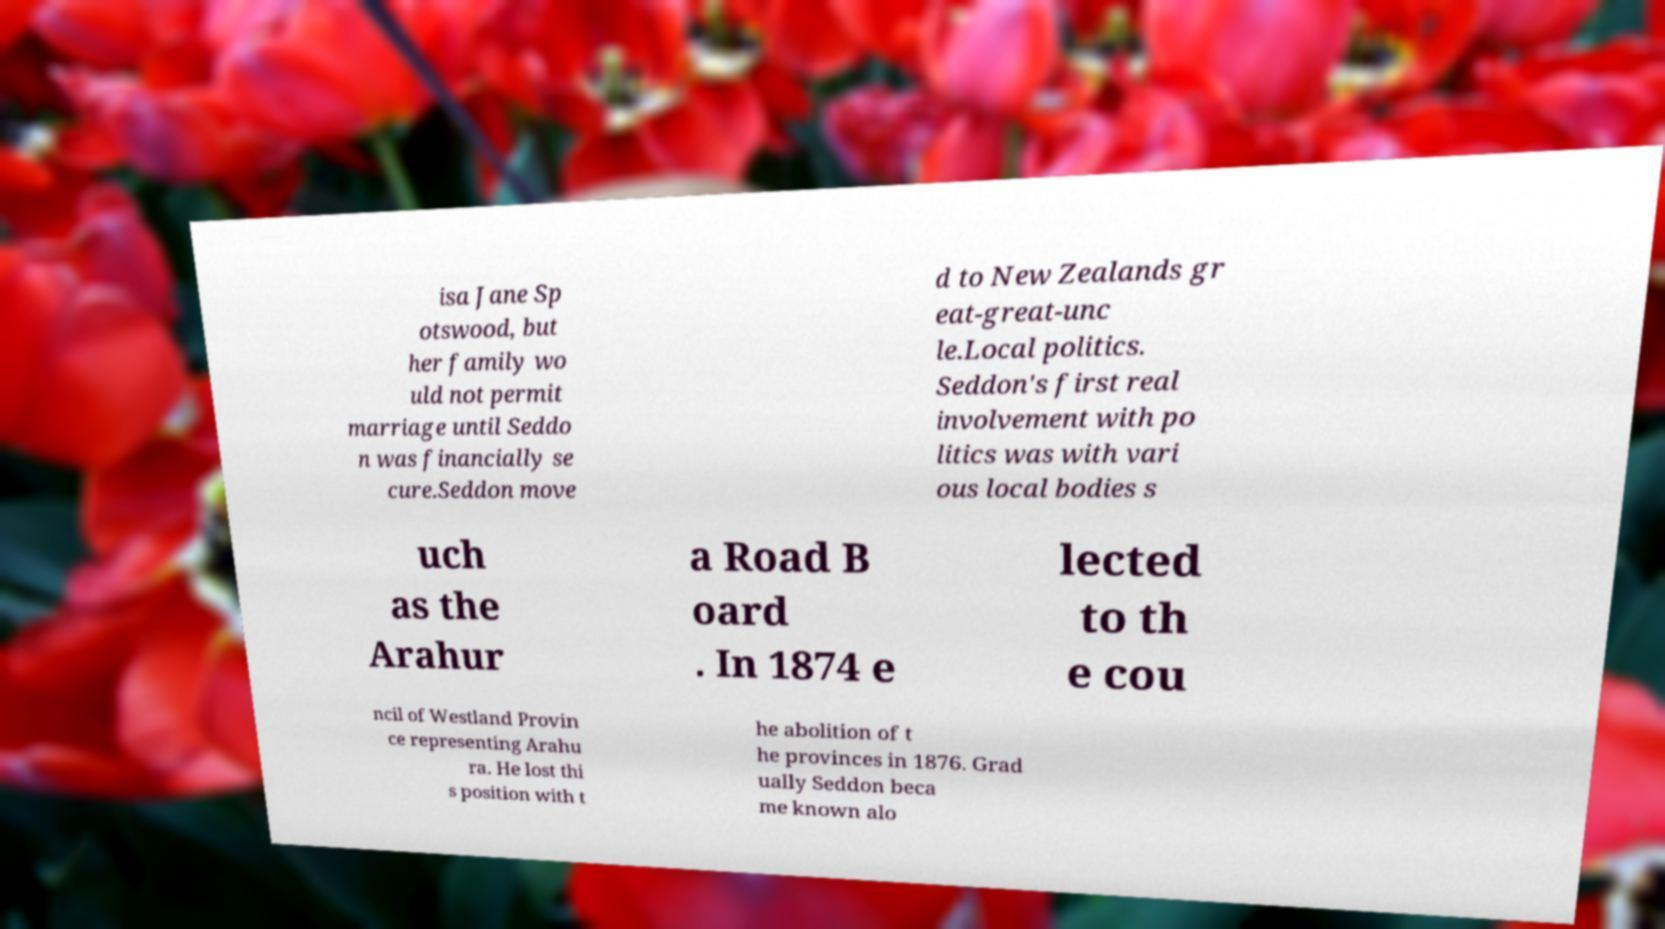There's text embedded in this image that I need extracted. Can you transcribe it verbatim? isa Jane Sp otswood, but her family wo uld not permit marriage until Seddo n was financially se cure.Seddon move d to New Zealands gr eat-great-unc le.Local politics. Seddon's first real involvement with po litics was with vari ous local bodies s uch as the Arahur a Road B oard . In 1874 e lected to th e cou ncil of Westland Provin ce representing Arahu ra. He lost thi s position with t he abolition of t he provinces in 1876. Grad ually Seddon beca me known alo 